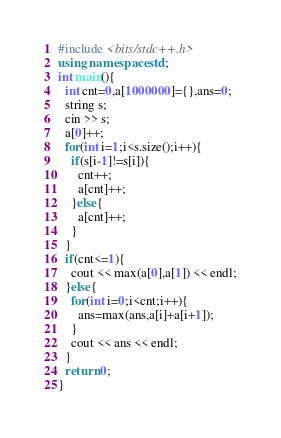<code> <loc_0><loc_0><loc_500><loc_500><_C++_>#include <bits/stdc++.h>
using namespace std;
int main(){
  int cnt=0,a[1000000]={},ans=0;
  string s;
  cin >> s;
  a[0]++;
  for(int i=1;i<s.size();i++){
    if(s[i-1]!=s[i]){
      cnt++;
      a[cnt]++;
    }else{
      a[cnt]++;
    }
  }
  if(cnt<=1){
    cout << max(a[0],a[1]) << endl;
  }else{
    for(int i=0;i<cnt;i++){
      ans=max(ans,a[i]+a[i+1]);
    }
    cout << ans << endl;
  }
  return 0;
}</code> 